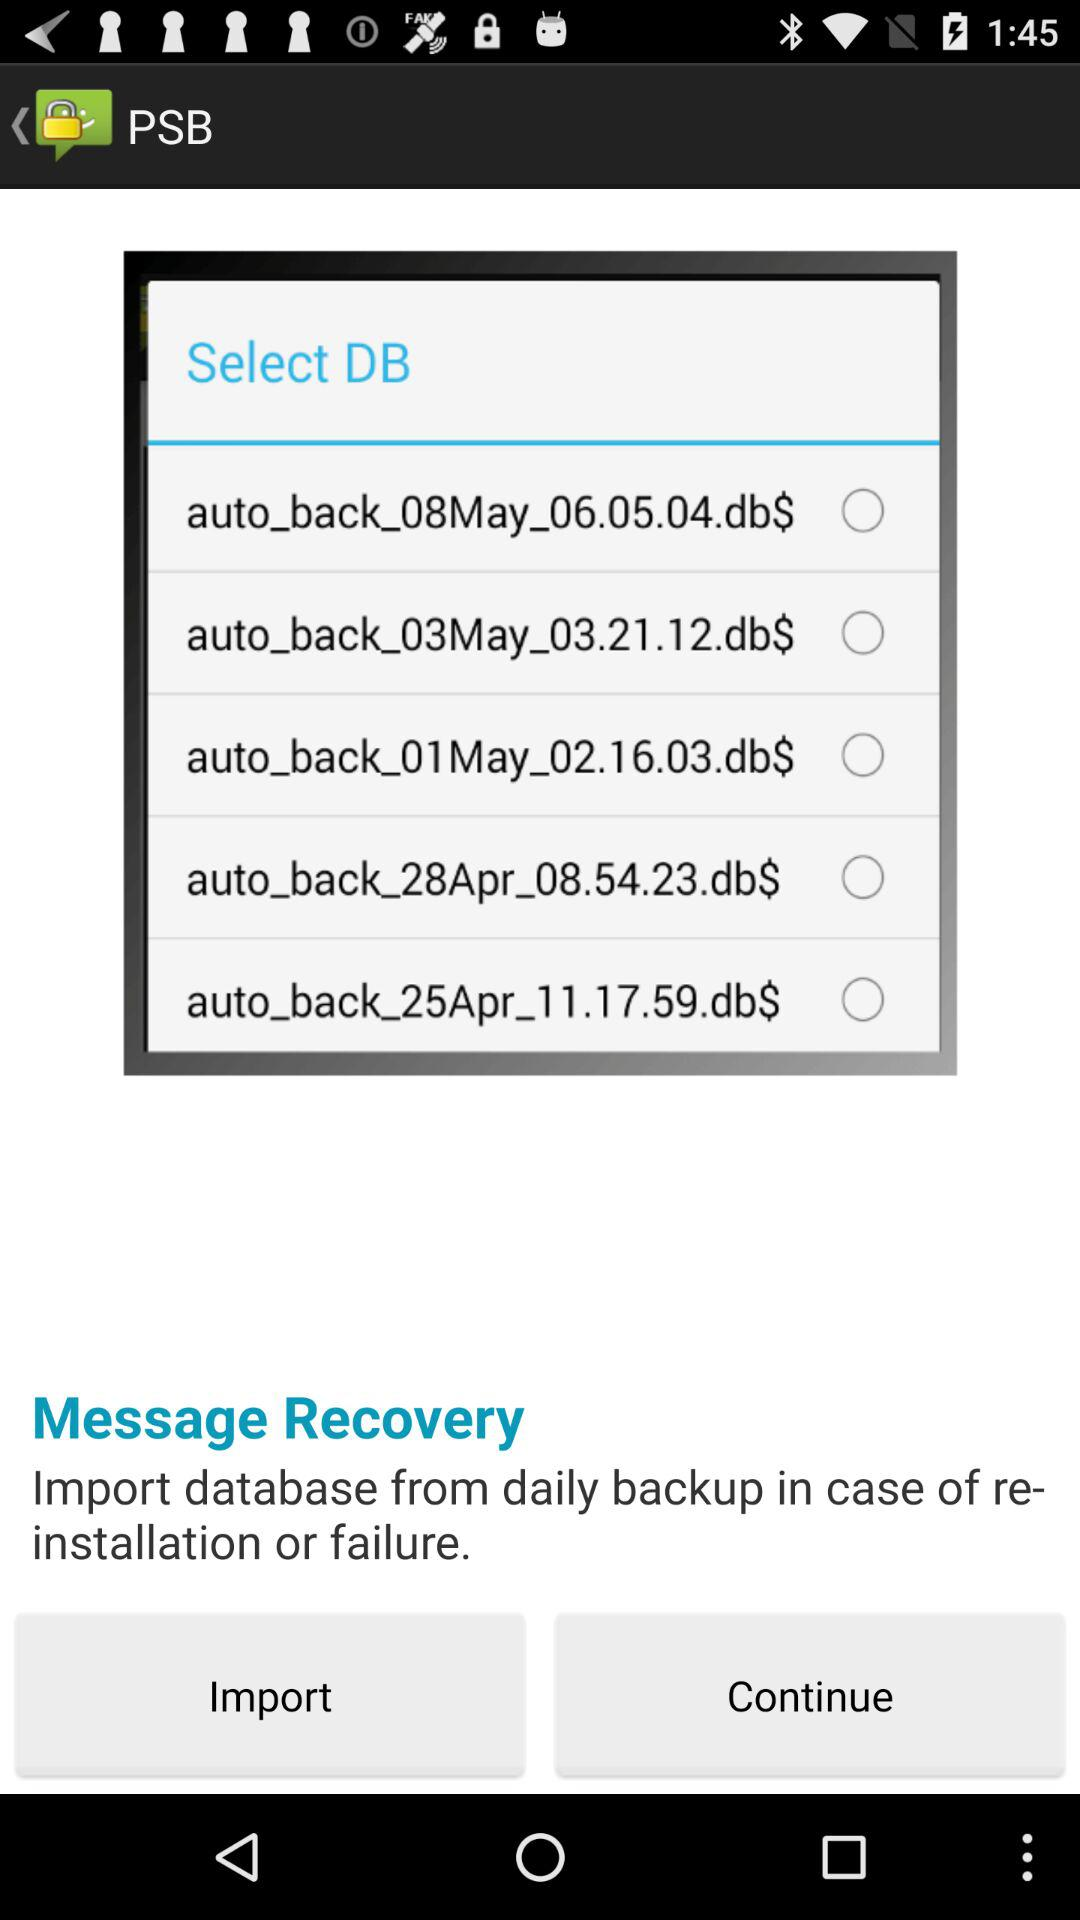Can you explain what the '$' symbol at the end of each filename indicates? The '$' symbol at the end of each filename often signifies a special or hidden file in different operating systems, but its exact meaning can vary depending on the context within the software application displayed. 